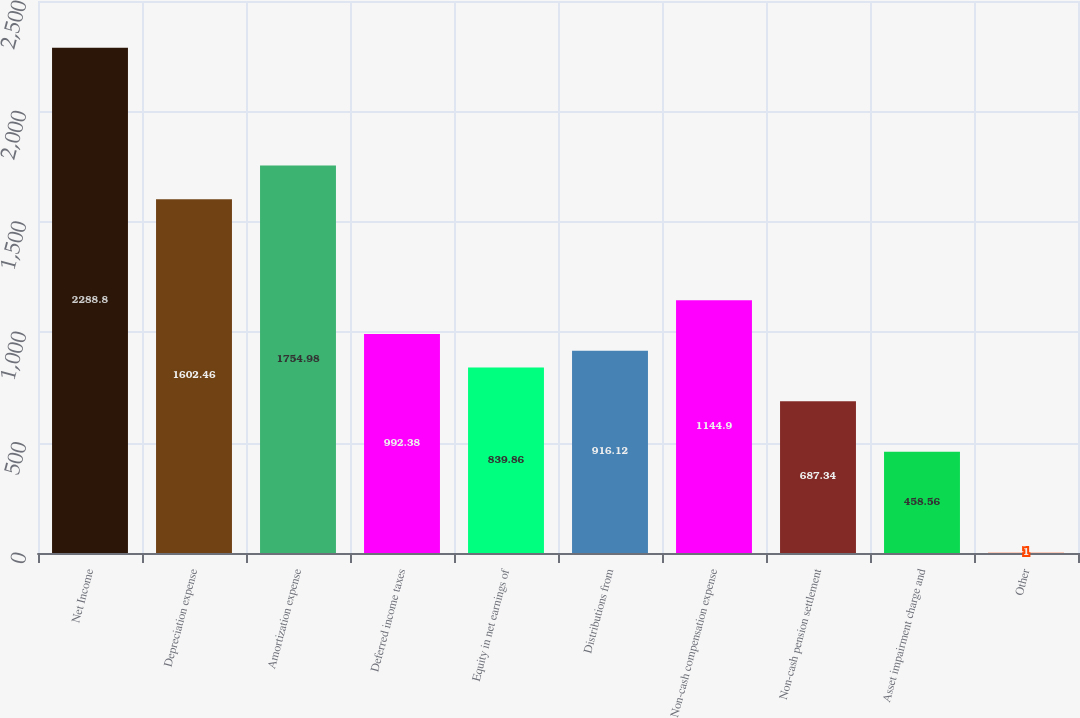Convert chart to OTSL. <chart><loc_0><loc_0><loc_500><loc_500><bar_chart><fcel>Net Income<fcel>Depreciation expense<fcel>Amortization expense<fcel>Deferred income taxes<fcel>Equity in net earnings of<fcel>Distributions from<fcel>Non-cash compensation expense<fcel>Non-cash pension settlement<fcel>Asset impairment charge and<fcel>Other<nl><fcel>2288.8<fcel>1602.46<fcel>1754.98<fcel>992.38<fcel>839.86<fcel>916.12<fcel>1144.9<fcel>687.34<fcel>458.56<fcel>1<nl></chart> 